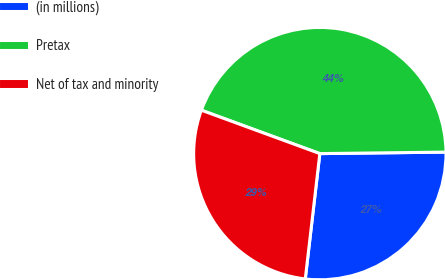Convert chart. <chart><loc_0><loc_0><loc_500><loc_500><pie_chart><fcel>(in millions)<fcel>Pretax<fcel>Net of tax and minority<nl><fcel>27.03%<fcel>44.22%<fcel>28.75%<nl></chart> 